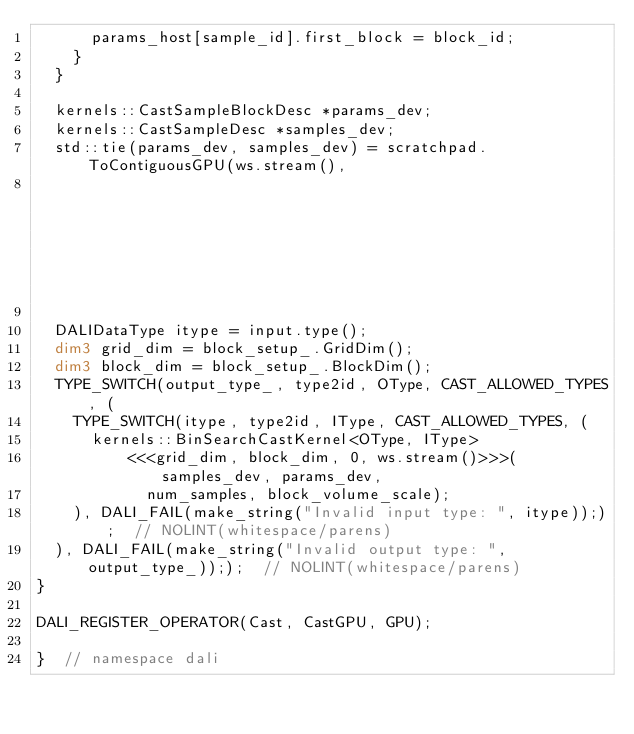<code> <loc_0><loc_0><loc_500><loc_500><_Cuda_>      params_host[sample_id].first_block = block_id;
    }
  }

  kernels::CastSampleBlockDesc *params_dev;
  kernels::CastSampleDesc *samples_dev;
  std::tie(params_dev, samples_dev) = scratchpad.ToContiguousGPU(ws.stream(),
                                                                 params_host, samples_);

  DALIDataType itype = input.type();
  dim3 grid_dim = block_setup_.GridDim();
  dim3 block_dim = block_setup_.BlockDim();
  TYPE_SWITCH(output_type_, type2id, OType, CAST_ALLOWED_TYPES, (
    TYPE_SWITCH(itype, type2id, IType, CAST_ALLOWED_TYPES, (
      kernels::BinSearchCastKernel<OType, IType>
          <<<grid_dim, block_dim, 0, ws.stream()>>>(samples_dev, params_dev,
            num_samples, block_volume_scale);
    ), DALI_FAIL(make_string("Invalid input type: ", itype)););  // NOLINT(whitespace/parens)
  ), DALI_FAIL(make_string("Invalid output type: ", output_type_)););  // NOLINT(whitespace/parens)
}

DALI_REGISTER_OPERATOR(Cast, CastGPU, GPU);

}  // namespace dali
</code> 